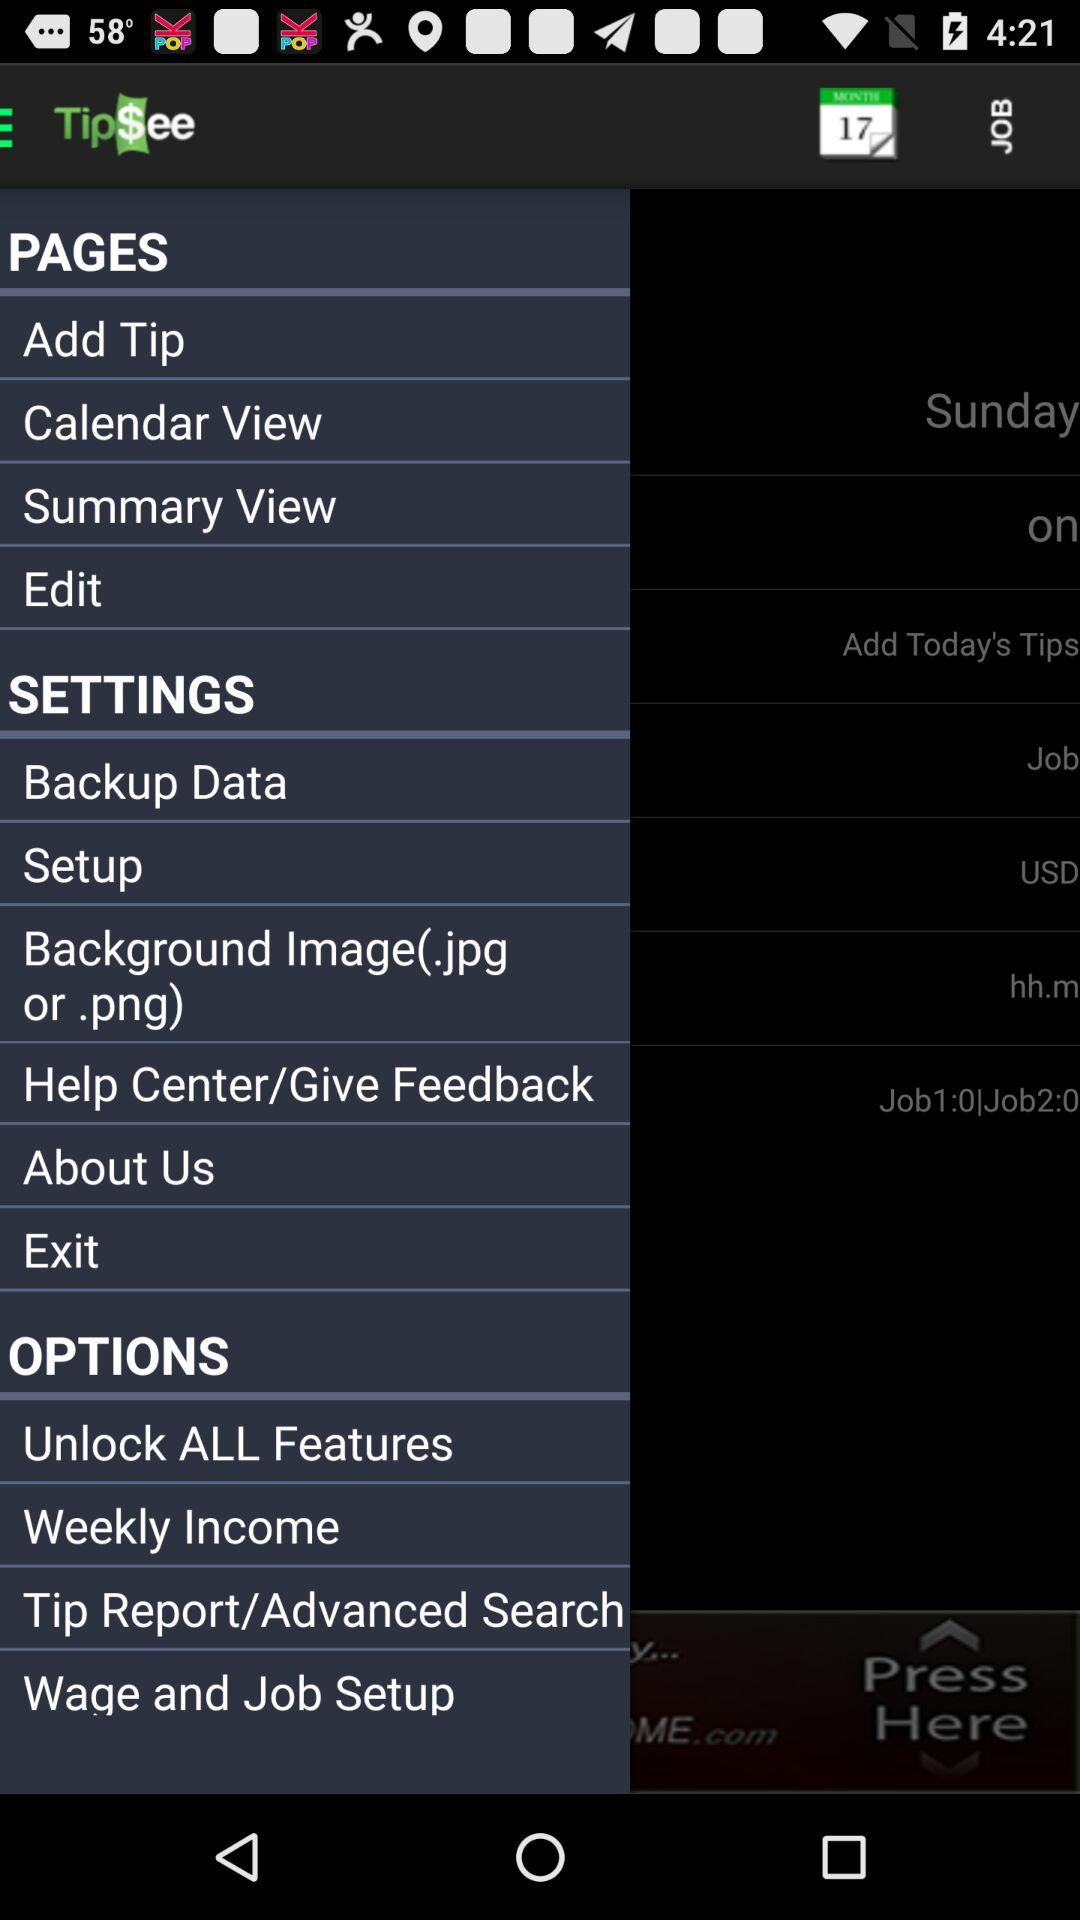What is the name of the application? The name of the application is "Tip$ee". 